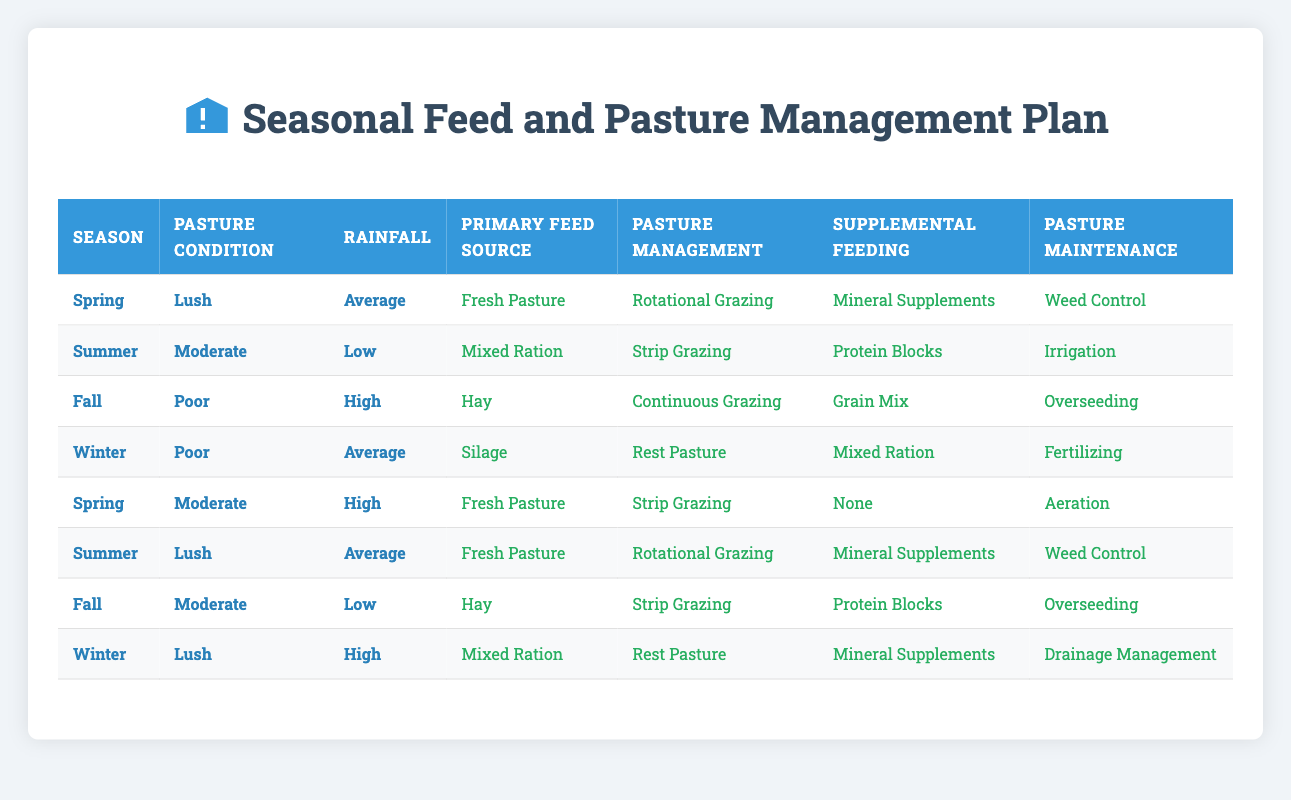What are the primary feed sources used in Spring? In the table, when we look at the rows for Spring, we see two different scenarios: "Lush" with "Average" rainfall suggests a primary feed source of "Fresh Pasture," and "Moderate" with "High" rainfall also indicates "Fresh Pasture." Therefore, the primary feed source in Spring is consistent across these scenarios.
Answer: Fresh Pasture Which pasture management method is used when the pasture condition is poor in Fall? In the Fall row, looking specifically at the "Poor" pasture condition with "High" rainfall, the identified pasture management method is "Continuous Grazing." This method is consistent for that condition in the table.
Answer: Continuous Grazing Is "Protein Blocks" offered as supplemental feeding in Winter with poor pasture condition? Referring to the Winter row with "Poor" pasture condition and "Average" rainfall, it indicates that "Mixed Ration" is the supplemental feeding, not "Protein Blocks." Therefore, this statement is false.
Answer: No What is the recommended pasture maintenance when the rainfall is low in Summer? From the Summer row under "Moderate" pasture condition and "Low" rainfall, the pasture maintenance recommended is "Irrigation." Since this is a single scenario for the conditions, the answer is straightforward.
Answer: Irrigation How many different primary feed sources are indicated across all seasons? Analyzing the table, we see the primary feed sources listed: "Fresh Pasture," "Hay," "Silage," and "Mixed Ration." Counting these distinct options gives us four different sources used across all seasons.
Answer: 4 When is "Overseeding" recommended for pasture maintenance? Looking through the rows, "Overseeding" appears in two scenarios: Fall when the pasture condition is "Poor" under "High" rainfall and Summer when the pasture condition is "Moderate" under "Low" rainfall. Both scenarios recommend this maintenance practice.
Answer: Fall, Summer What is the primary feed source when the pasture condition is lush and rainfall is average? From the Spring row classified under "Lush" pasture condition with "Average" rainfall, the primary feed source identified is "Fresh Pasture." This condition specifies only one feed source in the table.
Answer: Fresh Pasture In which season is "Silage" utilized as the primary feed source? Referring to the Winter row with a "Poor" pasture condition and "Average" rainfall, "Silage" is specifically listed as the primary feed source for that scenario. Thus, it is clear that "Silage" is utilized in Winter.
Answer: Winter 